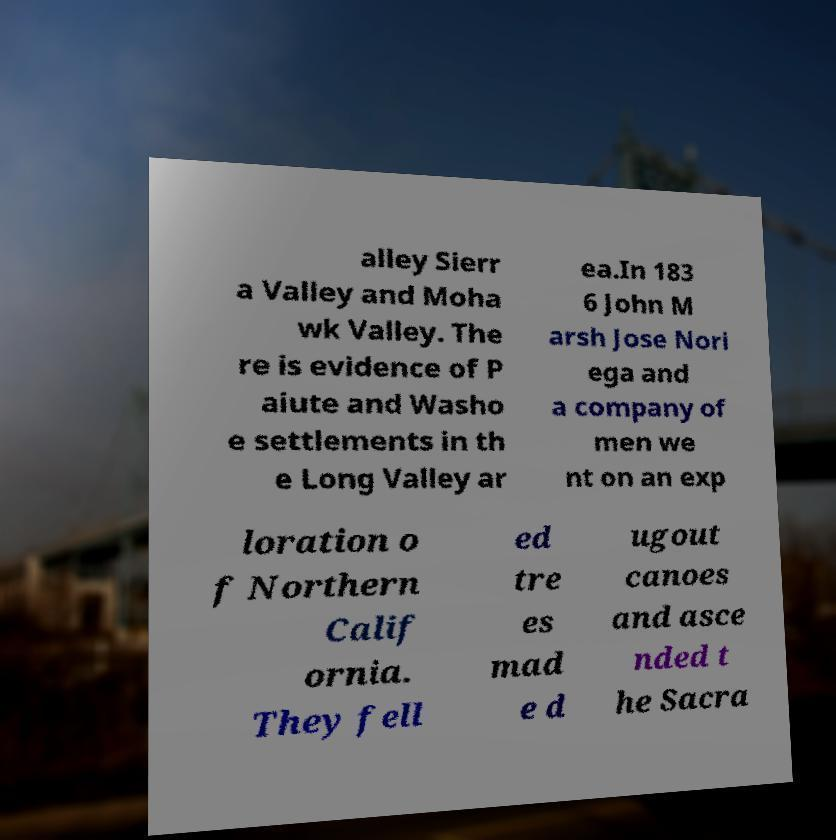Can you accurately transcribe the text from the provided image for me? alley Sierr a Valley and Moha wk Valley. The re is evidence of P aiute and Washo e settlements in th e Long Valley ar ea.In 183 6 John M arsh Jose Nori ega and a company of men we nt on an exp loration o f Northern Calif ornia. They fell ed tre es mad e d ugout canoes and asce nded t he Sacra 